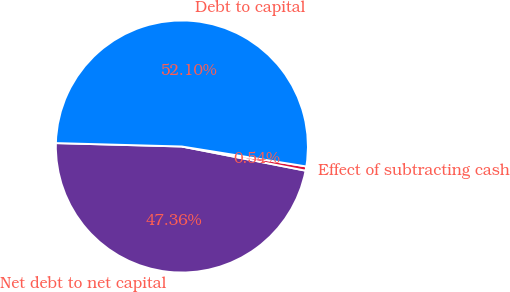Convert chart. <chart><loc_0><loc_0><loc_500><loc_500><pie_chart><fcel>Net debt to net capital<fcel>Effect of subtracting cash<fcel>Debt to capital<nl><fcel>47.36%<fcel>0.54%<fcel>52.1%<nl></chart> 